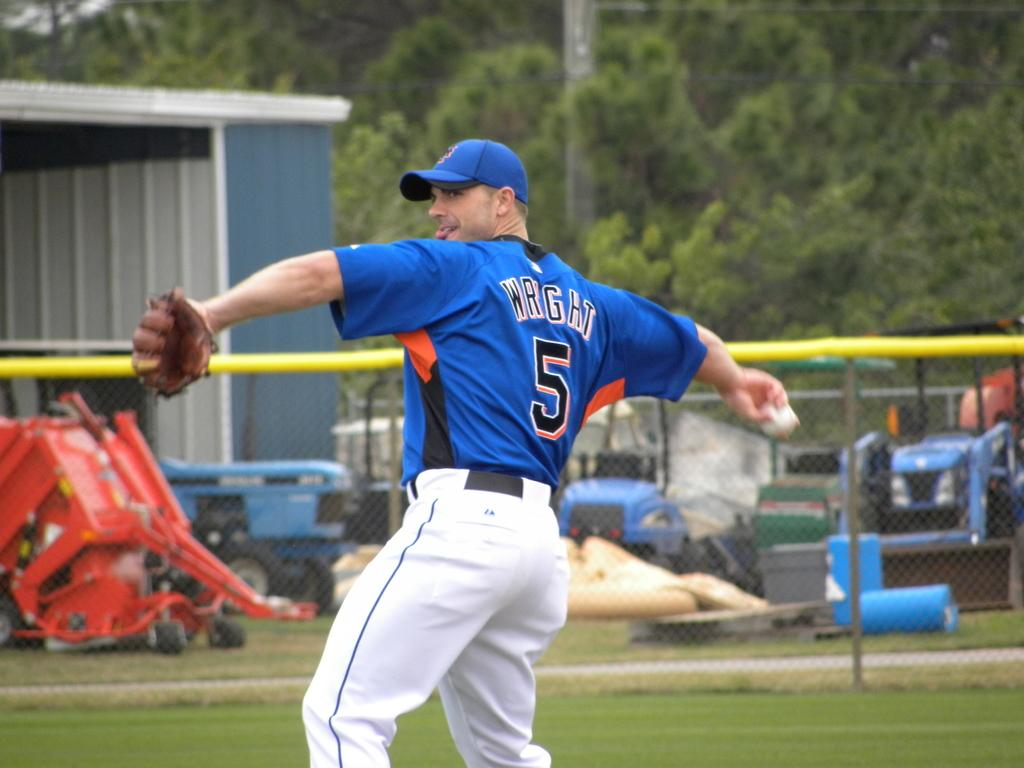<image>
Present a compact description of the photo's key features. a baseball player with the name Wright on his jersey #5. 